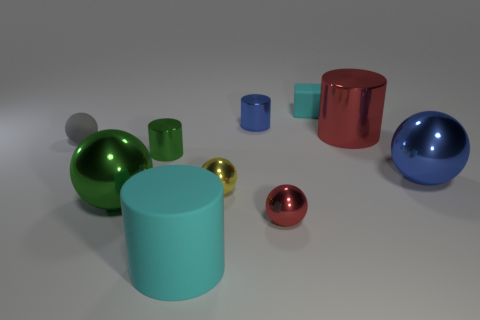There is a red thing to the right of the cyan thing that is right of the tiny blue shiny object; what is its shape?
Your answer should be very brief. Cylinder. There is a large cyan matte cylinder in front of the cyan matte object to the right of the large matte object; how many tiny shiny cylinders are on the right side of it?
Your answer should be very brief. 1. Are there fewer large blue metallic spheres that are left of the small cyan matte thing than big red shiny objects?
Provide a short and direct response. Yes. Is there any other thing that has the same shape as the small yellow metallic object?
Give a very brief answer. Yes. What is the shape of the red metal thing that is in front of the tiny matte ball?
Your response must be concise. Sphere. What is the shape of the red metal thing on the left side of the cyan rubber thing that is behind the cyan matte thing in front of the big green shiny object?
Offer a terse response. Sphere. What number of objects are cyan matte cylinders or large green matte blocks?
Your answer should be compact. 1. There is a tiny metallic object left of the large rubber cylinder; is its shape the same as the cyan thing in front of the big blue thing?
Your response must be concise. Yes. How many metal balls are to the right of the red metallic sphere and on the left side of the yellow object?
Provide a succinct answer. 0. What number of other things are there of the same size as the gray matte sphere?
Make the answer very short. 5. 